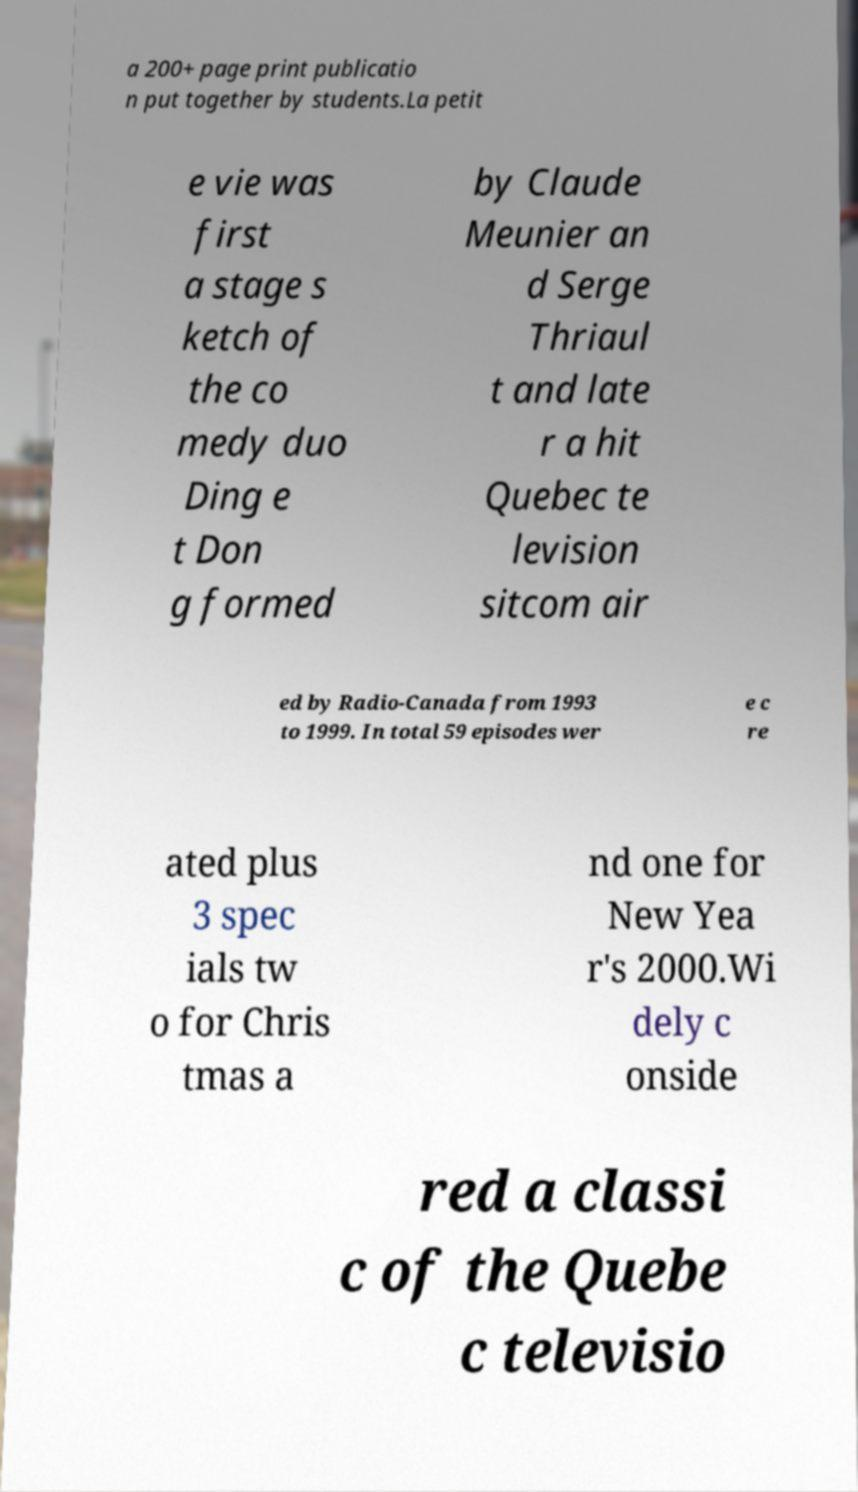Could you extract and type out the text from this image? a 200+ page print publicatio n put together by students.La petit e vie was first a stage s ketch of the co medy duo Ding e t Don g formed by Claude Meunier an d Serge Thriaul t and late r a hit Quebec te levision sitcom air ed by Radio-Canada from 1993 to 1999. In total 59 episodes wer e c re ated plus 3 spec ials tw o for Chris tmas a nd one for New Yea r's 2000.Wi dely c onside red a classi c of the Quebe c televisio 